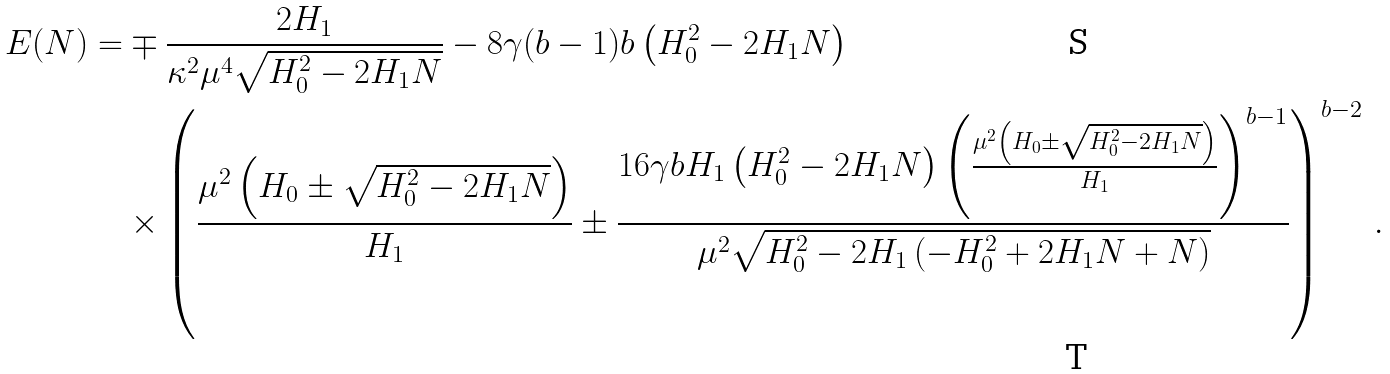Convert formula to latex. <formula><loc_0><loc_0><loc_500><loc_500>E ( N ) = & \mp \frac { 2 H _ { 1 } } { \kappa ^ { 2 } \mu ^ { 4 } \sqrt { H _ { 0 } ^ { 2 } - 2 H _ { 1 } N } } - 8 \gamma ( b - 1 ) b \left ( H _ { 0 } ^ { 2 } - 2 H _ { 1 } N \right ) \\ & \times \left ( \frac { \mu ^ { 2 } \left ( H _ { 0 } \pm \sqrt { H _ { 0 } ^ { 2 } - 2 H _ { 1 } N } \right ) } { H _ { 1 } } \pm \frac { 1 6 \gamma b H _ { 1 } \left ( H _ { 0 } ^ { 2 } - 2 H _ { 1 } N \right ) \left ( \frac { \mu ^ { 2 } \left ( H _ { 0 } \pm \sqrt { H _ { 0 } ^ { 2 } - 2 H _ { 1 } N } \right ) } { H _ { 1 } } \right ) ^ { b - 1 } } { \mu ^ { 2 } \sqrt { H _ { 0 } ^ { 2 } - 2 H _ { 1 } \left ( - H _ { 0 } ^ { 2 } + 2 H _ { 1 } N + N \right ) } } \right ) ^ { b - 2 } \, .</formula> 